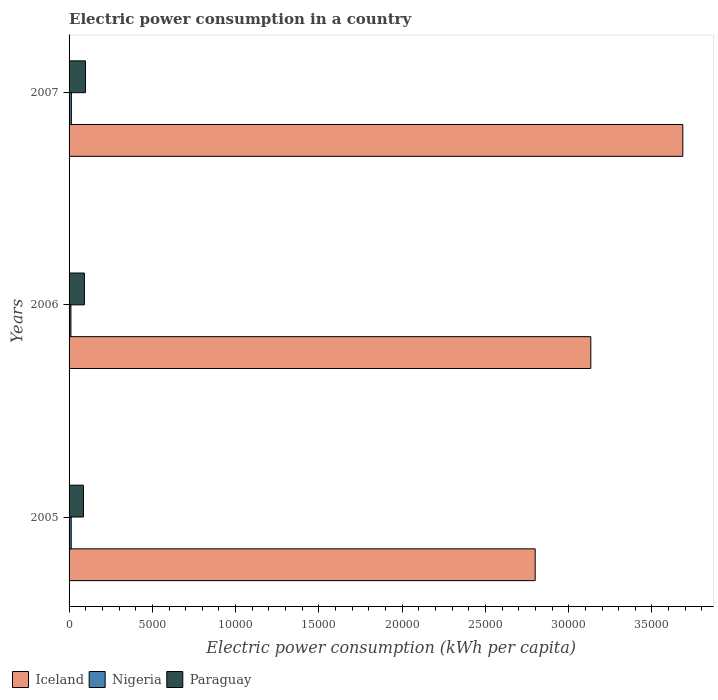How many different coloured bars are there?
Your answer should be compact. 3. How many groups of bars are there?
Your answer should be compact. 3. Are the number of bars per tick equal to the number of legend labels?
Your answer should be compact. Yes. Are the number of bars on each tick of the Y-axis equal?
Ensure brevity in your answer.  Yes. How many bars are there on the 1st tick from the bottom?
Your answer should be very brief. 3. What is the electric power consumption in in Iceland in 2007?
Your response must be concise. 3.69e+04. Across all years, what is the maximum electric power consumption in in Iceland?
Keep it short and to the point. 3.69e+04. Across all years, what is the minimum electric power consumption in in Nigeria?
Give a very brief answer. 111.14. In which year was the electric power consumption in in Paraguay maximum?
Ensure brevity in your answer.  2007. What is the total electric power consumption in in Nigeria in the graph?
Your response must be concise. 377.92. What is the difference between the electric power consumption in in Nigeria in 2006 and that in 2007?
Provide a succinct answer. -27. What is the difference between the electric power consumption in in Iceland in 2006 and the electric power consumption in in Paraguay in 2007?
Make the answer very short. 3.03e+04. What is the average electric power consumption in in Paraguay per year?
Your response must be concise. 922.88. In the year 2006, what is the difference between the electric power consumption in in Nigeria and electric power consumption in in Iceland?
Provide a succinct answer. -3.12e+04. What is the ratio of the electric power consumption in in Iceland in 2006 to that in 2007?
Keep it short and to the point. 0.85. Is the electric power consumption in in Iceland in 2005 less than that in 2007?
Offer a very short reply. Yes. Is the difference between the electric power consumption in in Nigeria in 2005 and 2007 greater than the difference between the electric power consumption in in Iceland in 2005 and 2007?
Make the answer very short. Yes. What is the difference between the highest and the second highest electric power consumption in in Nigeria?
Your answer should be compact. 9.51. What is the difference between the highest and the lowest electric power consumption in in Paraguay?
Offer a very short reply. 120.28. In how many years, is the electric power consumption in in Paraguay greater than the average electric power consumption in in Paraguay taken over all years?
Your answer should be compact. 1. Is the sum of the electric power consumption in in Nigeria in 2006 and 2007 greater than the maximum electric power consumption in in Paraguay across all years?
Provide a short and direct response. No. What does the 2nd bar from the top in 2005 represents?
Your response must be concise. Nigeria. What does the 1st bar from the bottom in 2006 represents?
Provide a succinct answer. Iceland. Is it the case that in every year, the sum of the electric power consumption in in Iceland and electric power consumption in in Paraguay is greater than the electric power consumption in in Nigeria?
Offer a terse response. Yes. Are all the bars in the graph horizontal?
Give a very brief answer. Yes. What is the difference between two consecutive major ticks on the X-axis?
Offer a terse response. 5000. Are the values on the major ticks of X-axis written in scientific E-notation?
Provide a succinct answer. No. Does the graph contain grids?
Your answer should be very brief. No. What is the title of the graph?
Make the answer very short. Electric power consumption in a country. What is the label or title of the X-axis?
Your response must be concise. Electric power consumption (kWh per capita). What is the Electric power consumption (kWh per capita) in Iceland in 2005?
Ensure brevity in your answer.  2.80e+04. What is the Electric power consumption (kWh per capita) of Nigeria in 2005?
Make the answer very short. 128.64. What is the Electric power consumption (kWh per capita) in Paraguay in 2005?
Your response must be concise. 863.77. What is the Electric power consumption (kWh per capita) in Iceland in 2006?
Provide a succinct answer. 3.13e+04. What is the Electric power consumption (kWh per capita) of Nigeria in 2006?
Provide a short and direct response. 111.14. What is the Electric power consumption (kWh per capita) in Paraguay in 2006?
Offer a very short reply. 920.82. What is the Electric power consumption (kWh per capita) in Iceland in 2007?
Keep it short and to the point. 3.69e+04. What is the Electric power consumption (kWh per capita) of Nigeria in 2007?
Keep it short and to the point. 138.14. What is the Electric power consumption (kWh per capita) of Paraguay in 2007?
Offer a terse response. 984.05. Across all years, what is the maximum Electric power consumption (kWh per capita) of Iceland?
Offer a terse response. 3.69e+04. Across all years, what is the maximum Electric power consumption (kWh per capita) of Nigeria?
Ensure brevity in your answer.  138.14. Across all years, what is the maximum Electric power consumption (kWh per capita) in Paraguay?
Keep it short and to the point. 984.05. Across all years, what is the minimum Electric power consumption (kWh per capita) of Iceland?
Offer a terse response. 2.80e+04. Across all years, what is the minimum Electric power consumption (kWh per capita) in Nigeria?
Provide a succinct answer. 111.14. Across all years, what is the minimum Electric power consumption (kWh per capita) of Paraguay?
Your response must be concise. 863.77. What is the total Electric power consumption (kWh per capita) of Iceland in the graph?
Keep it short and to the point. 9.62e+04. What is the total Electric power consumption (kWh per capita) of Nigeria in the graph?
Your answer should be compact. 377.92. What is the total Electric power consumption (kWh per capita) in Paraguay in the graph?
Offer a terse response. 2768.65. What is the difference between the Electric power consumption (kWh per capita) of Iceland in 2005 and that in 2006?
Offer a very short reply. -3340.36. What is the difference between the Electric power consumption (kWh per capita) in Nigeria in 2005 and that in 2006?
Give a very brief answer. 17.49. What is the difference between the Electric power consumption (kWh per capita) in Paraguay in 2005 and that in 2006?
Your answer should be compact. -57.05. What is the difference between the Electric power consumption (kWh per capita) in Iceland in 2005 and that in 2007?
Offer a terse response. -8864.52. What is the difference between the Electric power consumption (kWh per capita) of Nigeria in 2005 and that in 2007?
Give a very brief answer. -9.51. What is the difference between the Electric power consumption (kWh per capita) of Paraguay in 2005 and that in 2007?
Your answer should be very brief. -120.28. What is the difference between the Electric power consumption (kWh per capita) of Iceland in 2006 and that in 2007?
Keep it short and to the point. -5524.16. What is the difference between the Electric power consumption (kWh per capita) of Nigeria in 2006 and that in 2007?
Keep it short and to the point. -27. What is the difference between the Electric power consumption (kWh per capita) in Paraguay in 2006 and that in 2007?
Provide a succinct answer. -63.23. What is the difference between the Electric power consumption (kWh per capita) of Iceland in 2005 and the Electric power consumption (kWh per capita) of Nigeria in 2006?
Provide a succinct answer. 2.79e+04. What is the difference between the Electric power consumption (kWh per capita) of Iceland in 2005 and the Electric power consumption (kWh per capita) of Paraguay in 2006?
Your answer should be compact. 2.71e+04. What is the difference between the Electric power consumption (kWh per capita) in Nigeria in 2005 and the Electric power consumption (kWh per capita) in Paraguay in 2006?
Make the answer very short. -792.18. What is the difference between the Electric power consumption (kWh per capita) of Iceland in 2005 and the Electric power consumption (kWh per capita) of Nigeria in 2007?
Your answer should be compact. 2.78e+04. What is the difference between the Electric power consumption (kWh per capita) of Iceland in 2005 and the Electric power consumption (kWh per capita) of Paraguay in 2007?
Your answer should be very brief. 2.70e+04. What is the difference between the Electric power consumption (kWh per capita) in Nigeria in 2005 and the Electric power consumption (kWh per capita) in Paraguay in 2007?
Make the answer very short. -855.41. What is the difference between the Electric power consumption (kWh per capita) of Iceland in 2006 and the Electric power consumption (kWh per capita) of Nigeria in 2007?
Provide a short and direct response. 3.12e+04. What is the difference between the Electric power consumption (kWh per capita) of Iceland in 2006 and the Electric power consumption (kWh per capita) of Paraguay in 2007?
Provide a short and direct response. 3.03e+04. What is the difference between the Electric power consumption (kWh per capita) in Nigeria in 2006 and the Electric power consumption (kWh per capita) in Paraguay in 2007?
Offer a terse response. -872.91. What is the average Electric power consumption (kWh per capita) of Iceland per year?
Provide a short and direct response. 3.21e+04. What is the average Electric power consumption (kWh per capita) of Nigeria per year?
Your answer should be very brief. 125.97. What is the average Electric power consumption (kWh per capita) in Paraguay per year?
Ensure brevity in your answer.  922.88. In the year 2005, what is the difference between the Electric power consumption (kWh per capita) of Iceland and Electric power consumption (kWh per capita) of Nigeria?
Your answer should be very brief. 2.79e+04. In the year 2005, what is the difference between the Electric power consumption (kWh per capita) in Iceland and Electric power consumption (kWh per capita) in Paraguay?
Provide a short and direct response. 2.71e+04. In the year 2005, what is the difference between the Electric power consumption (kWh per capita) in Nigeria and Electric power consumption (kWh per capita) in Paraguay?
Your answer should be very brief. -735.14. In the year 2006, what is the difference between the Electric power consumption (kWh per capita) in Iceland and Electric power consumption (kWh per capita) in Nigeria?
Make the answer very short. 3.12e+04. In the year 2006, what is the difference between the Electric power consumption (kWh per capita) in Iceland and Electric power consumption (kWh per capita) in Paraguay?
Provide a succinct answer. 3.04e+04. In the year 2006, what is the difference between the Electric power consumption (kWh per capita) in Nigeria and Electric power consumption (kWh per capita) in Paraguay?
Make the answer very short. -809.68. In the year 2007, what is the difference between the Electric power consumption (kWh per capita) of Iceland and Electric power consumption (kWh per capita) of Nigeria?
Keep it short and to the point. 3.67e+04. In the year 2007, what is the difference between the Electric power consumption (kWh per capita) of Iceland and Electric power consumption (kWh per capita) of Paraguay?
Your answer should be very brief. 3.59e+04. In the year 2007, what is the difference between the Electric power consumption (kWh per capita) in Nigeria and Electric power consumption (kWh per capita) in Paraguay?
Your answer should be very brief. -845.91. What is the ratio of the Electric power consumption (kWh per capita) of Iceland in 2005 to that in 2006?
Ensure brevity in your answer.  0.89. What is the ratio of the Electric power consumption (kWh per capita) in Nigeria in 2005 to that in 2006?
Your answer should be very brief. 1.16. What is the ratio of the Electric power consumption (kWh per capita) in Paraguay in 2005 to that in 2006?
Your answer should be compact. 0.94. What is the ratio of the Electric power consumption (kWh per capita) in Iceland in 2005 to that in 2007?
Ensure brevity in your answer.  0.76. What is the ratio of the Electric power consumption (kWh per capita) of Nigeria in 2005 to that in 2007?
Provide a short and direct response. 0.93. What is the ratio of the Electric power consumption (kWh per capita) of Paraguay in 2005 to that in 2007?
Your answer should be very brief. 0.88. What is the ratio of the Electric power consumption (kWh per capita) of Iceland in 2006 to that in 2007?
Your answer should be compact. 0.85. What is the ratio of the Electric power consumption (kWh per capita) in Nigeria in 2006 to that in 2007?
Your response must be concise. 0.8. What is the ratio of the Electric power consumption (kWh per capita) of Paraguay in 2006 to that in 2007?
Ensure brevity in your answer.  0.94. What is the difference between the highest and the second highest Electric power consumption (kWh per capita) of Iceland?
Keep it short and to the point. 5524.16. What is the difference between the highest and the second highest Electric power consumption (kWh per capita) of Nigeria?
Keep it short and to the point. 9.51. What is the difference between the highest and the second highest Electric power consumption (kWh per capita) in Paraguay?
Your answer should be very brief. 63.23. What is the difference between the highest and the lowest Electric power consumption (kWh per capita) in Iceland?
Keep it short and to the point. 8864.52. What is the difference between the highest and the lowest Electric power consumption (kWh per capita) in Nigeria?
Provide a short and direct response. 27. What is the difference between the highest and the lowest Electric power consumption (kWh per capita) of Paraguay?
Give a very brief answer. 120.28. 